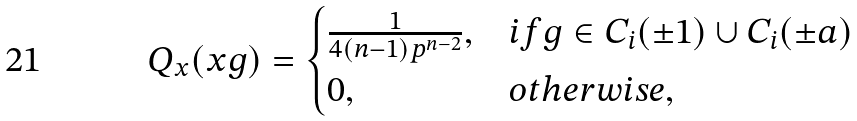<formula> <loc_0><loc_0><loc_500><loc_500>Q _ { x } ( x g ) = \begin{cases} \frac { 1 } { 4 ( n - 1 ) p ^ { n - 2 } } , & i f g \in C _ { i } ( \pm 1 ) \cup C _ { i } ( \pm a ) \\ 0 , & o t h e r w i s e , \end{cases}</formula> 